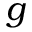Convert formula to latex. <formula><loc_0><loc_0><loc_500><loc_500>g</formula> 